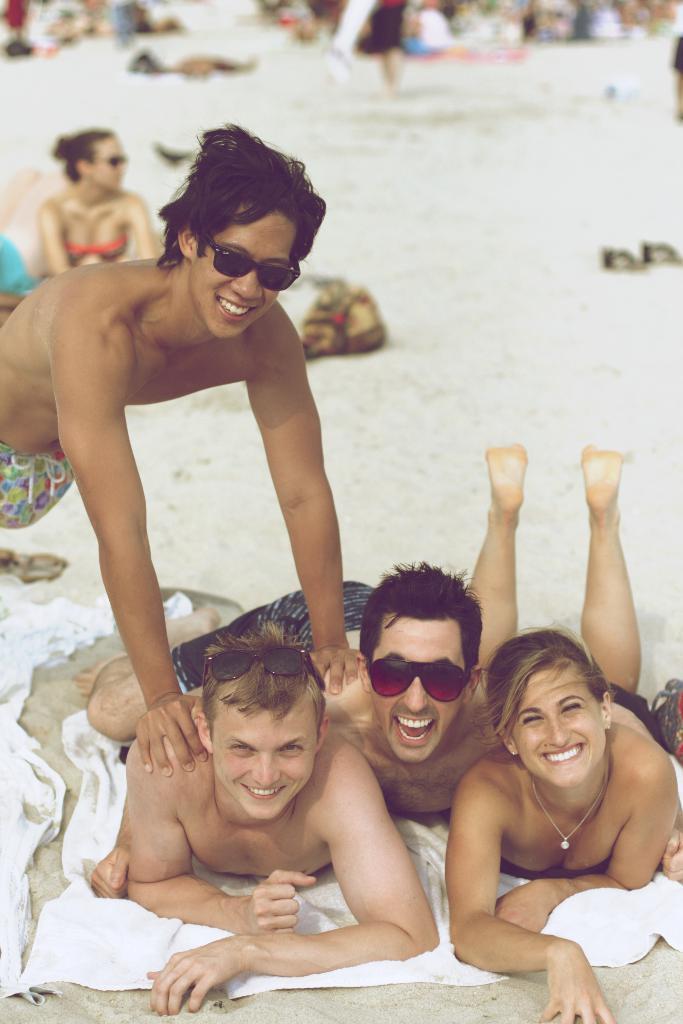Please provide a concise description of this image. In this image few people are lying on the cloth which is on the land. Left side there is a person wearing goggles. Few people are on the land having few objects on it. 